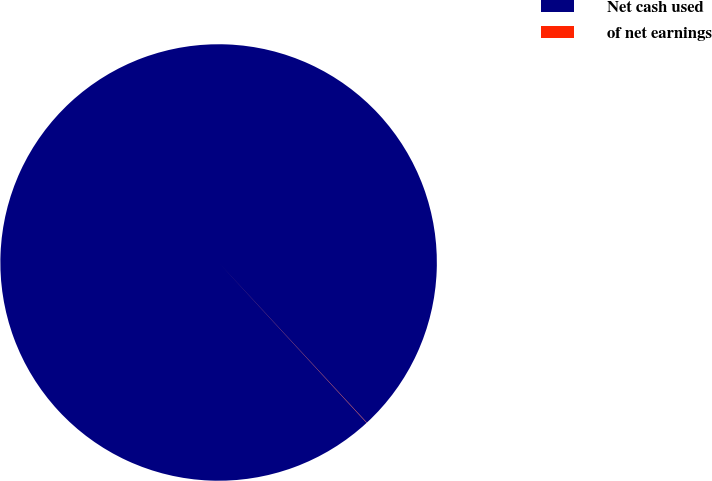<chart> <loc_0><loc_0><loc_500><loc_500><pie_chart><fcel>Net cash used<fcel>of net earnings<nl><fcel>99.98%<fcel>0.02%<nl></chart> 